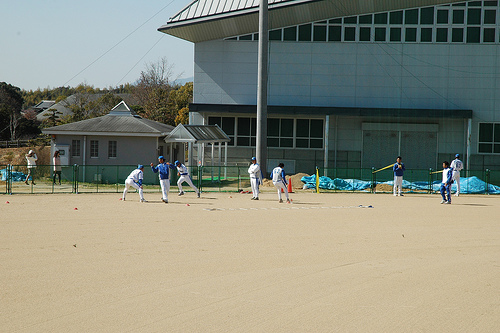<image>
Can you confirm if the building is in front of the man? Yes. The building is positioned in front of the man, appearing closer to the camera viewpoint. 